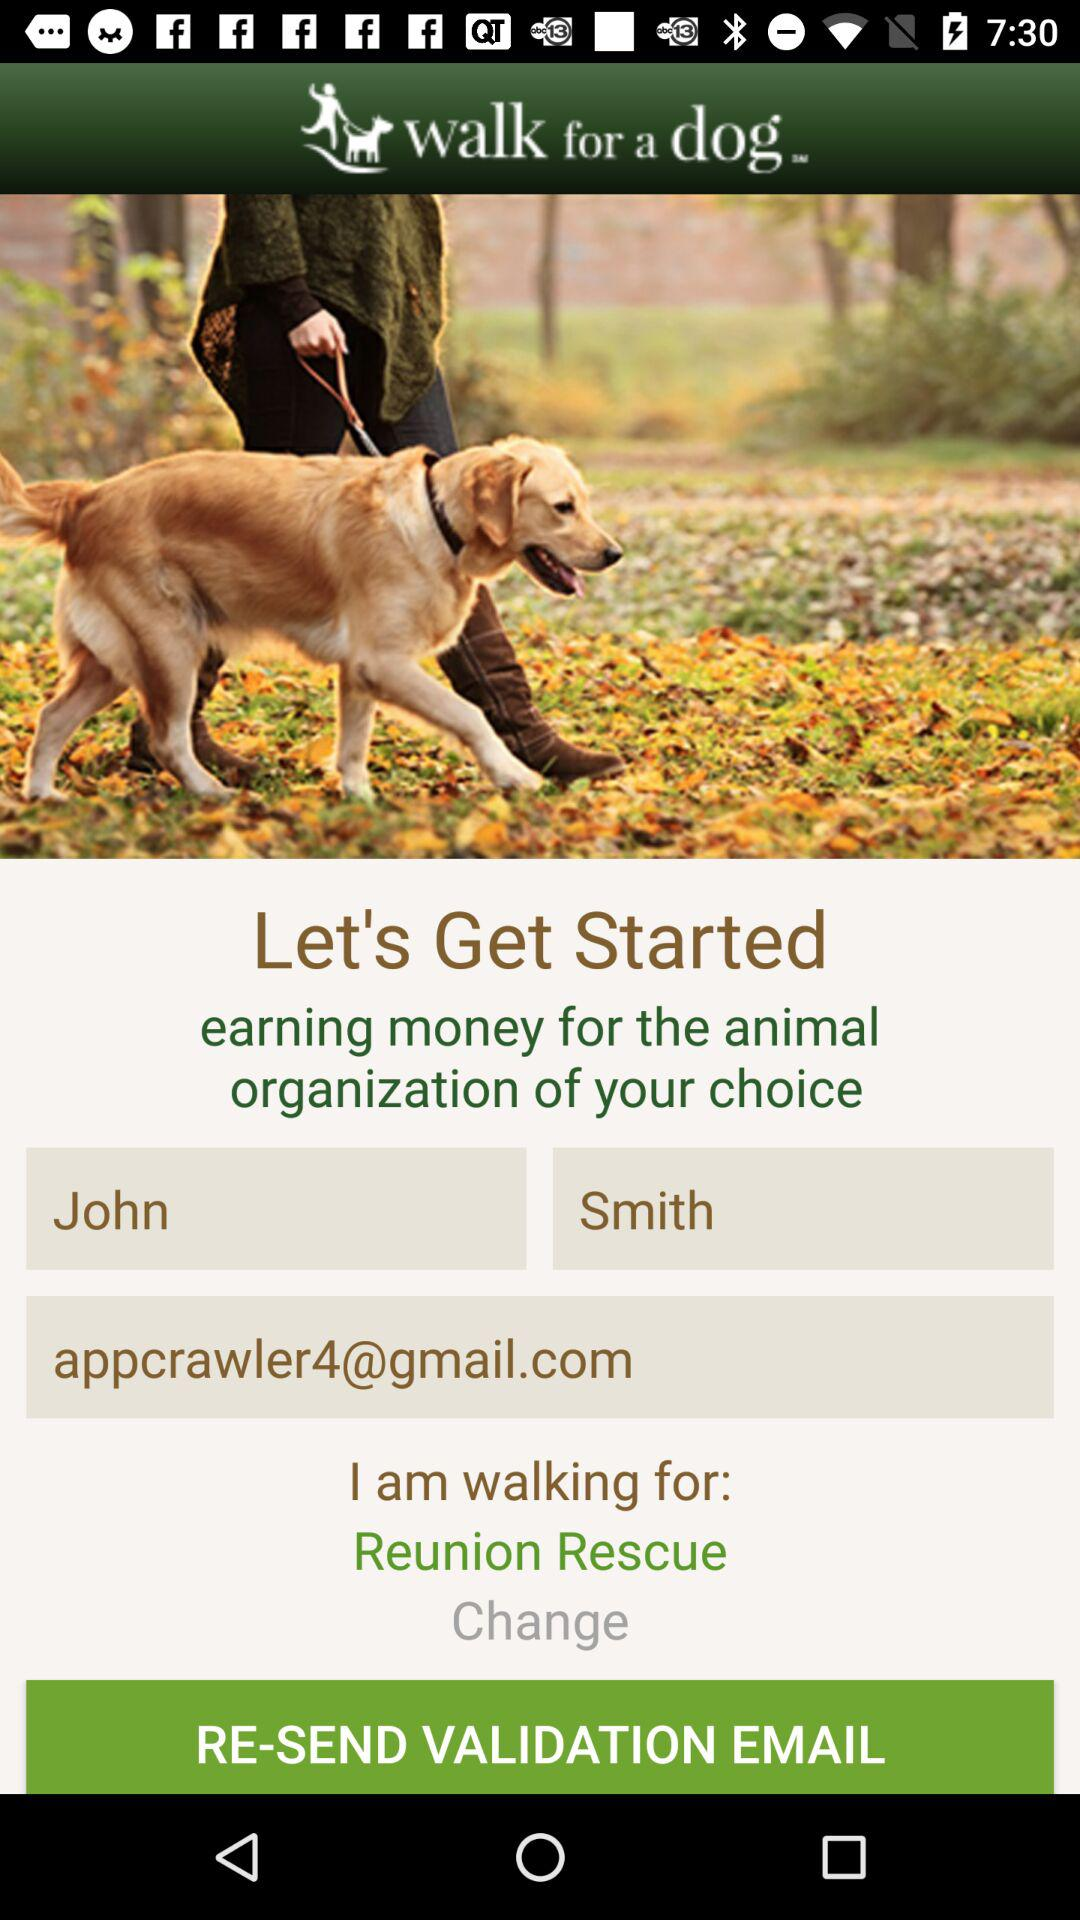What is the email address? The email address is appcrawler4@gmail.com. 